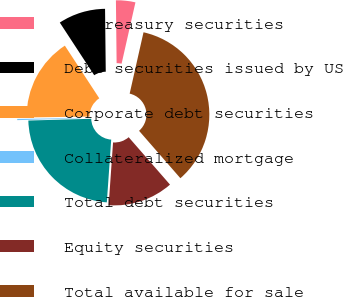<chart> <loc_0><loc_0><loc_500><loc_500><pie_chart><fcel>US treasury securities<fcel>Debt securities issued by US<fcel>Corporate debt securities<fcel>Collateralized mortgage<fcel>Total debt securities<fcel>Equity securities<fcel>Total available for sale<nl><fcel>3.71%<fcel>9.04%<fcel>16.0%<fcel>0.23%<fcel>23.44%<fcel>12.52%<fcel>35.05%<nl></chart> 